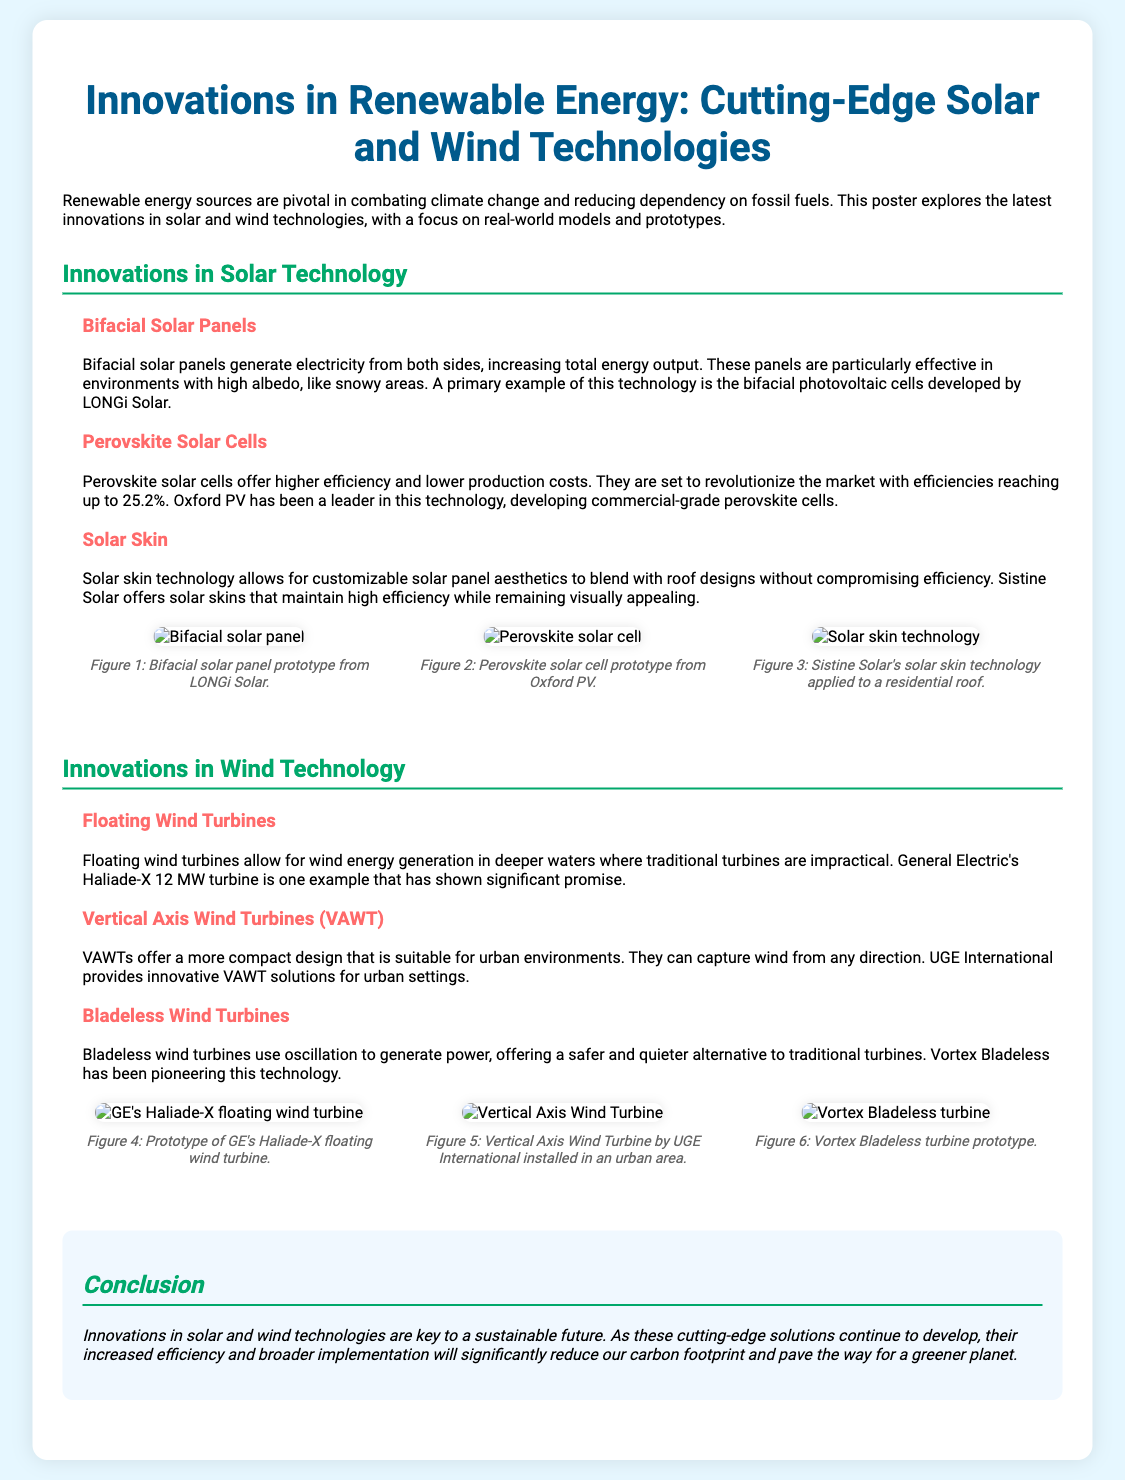What are bifacial solar panels? Bifacial solar panels generate electricity from both sides, increasing total energy output.
Answer: Electricity from both sides Who developed commercial-grade perovskite cells? Oxford PV has been a leader in this technology, developing commercial-grade perovskite cells.
Answer: Oxford PV What is the efficiency of perovskite solar cells? They are set to revolutionize the market with efficiencies reaching up to 25.2%.
Answer: 25.2% What type of wind turbine is suitable for urban environments? Vertical Axis Wind Turbines (VAWT) offer a more compact design suitable for urban environments.
Answer: Vertical Axis Wind Turbines (VAWT) What is the key benefit of floating wind turbines? Floating wind turbines allow for wind energy generation in deeper waters where traditional turbines are impractical.
Answer: Generation in deeper waters How do bladeless wind turbines generate power? Bladeless wind turbines use oscillation to generate power, offering a safer and quieter alternative.
Answer: Oscillation What technology allows customizable aesthetics for solar panels? Solar skin technology allows for customizable solar panel aesthetics.
Answer: Solar skin technology Which company provides innovative VAWT solutions? UGE International provides innovative VAWT solutions for urban settings.
Answer: UGE International What is a primary example of bifacial solar panel technology? A primary example of this technology is the bifacial photovoltaic cells developed by LONGi Solar.
Answer: LONGi Solar 